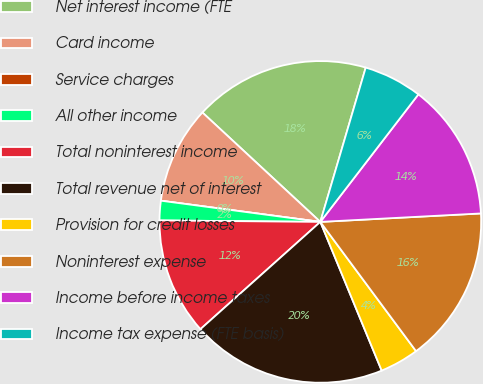Convert chart to OTSL. <chart><loc_0><loc_0><loc_500><loc_500><pie_chart><fcel>Net interest income (FTE<fcel>Card income<fcel>Service charges<fcel>All other income<fcel>Total noninterest income<fcel>Total revenue net of interest<fcel>Provision for credit losses<fcel>Noninterest expense<fcel>Income before income taxes<fcel>Income tax expense (FTE basis)<nl><fcel>17.65%<fcel>9.8%<fcel>0.0%<fcel>1.96%<fcel>11.76%<fcel>19.61%<fcel>3.92%<fcel>15.69%<fcel>13.73%<fcel>5.88%<nl></chart> 